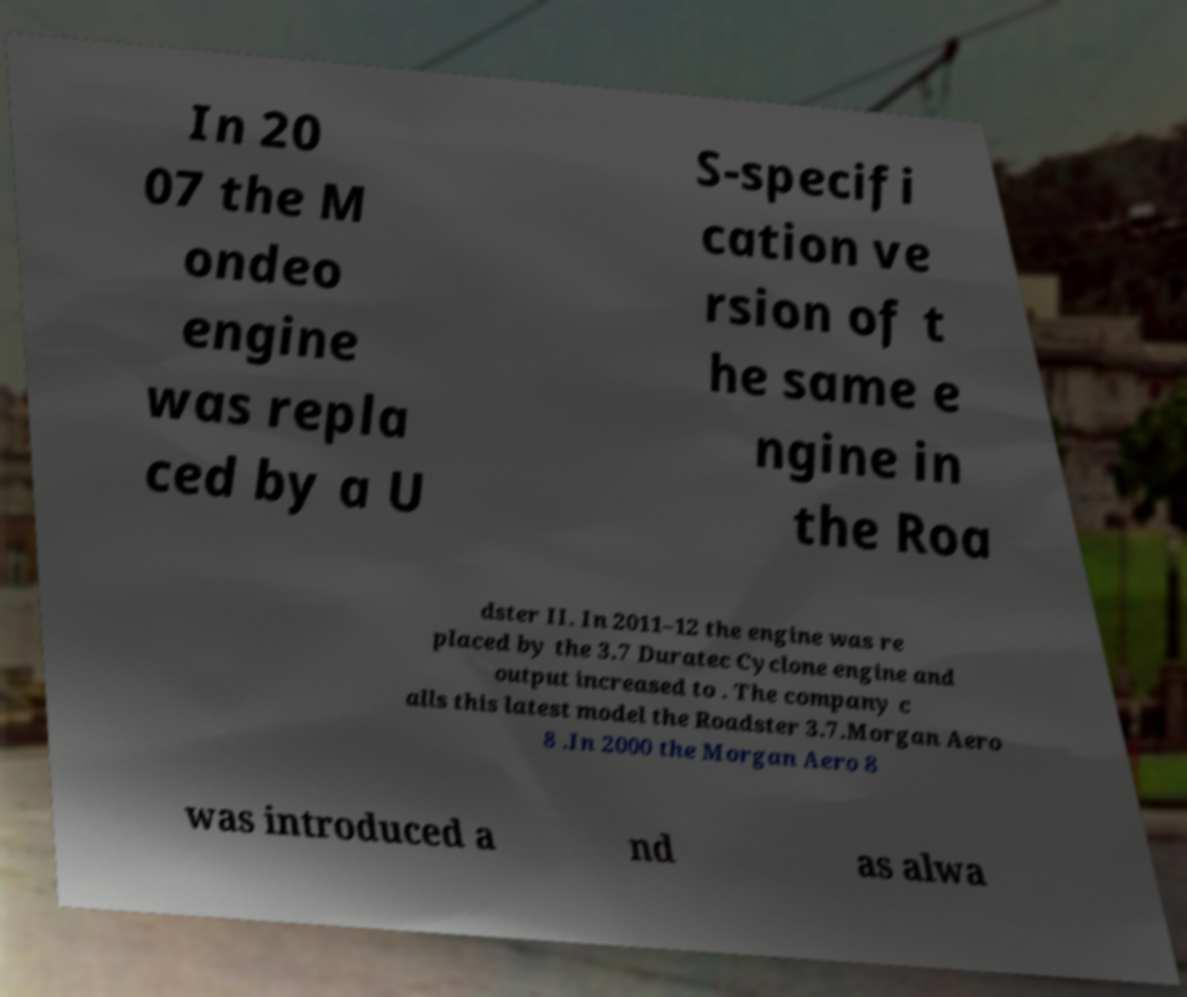Could you assist in decoding the text presented in this image and type it out clearly? In 20 07 the M ondeo engine was repla ced by a U S-specifi cation ve rsion of t he same e ngine in the Roa dster II. In 2011–12 the engine was re placed by the 3.7 Duratec Cyclone engine and output increased to . The company c alls this latest model the Roadster 3.7.Morgan Aero 8 .In 2000 the Morgan Aero 8 was introduced a nd as alwa 